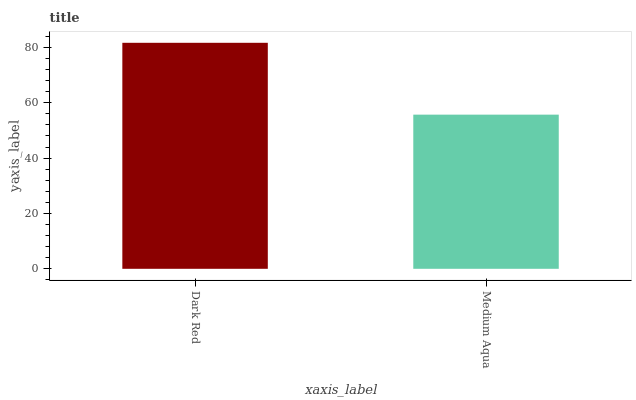Is Medium Aqua the maximum?
Answer yes or no. No. Is Dark Red greater than Medium Aqua?
Answer yes or no. Yes. Is Medium Aqua less than Dark Red?
Answer yes or no. Yes. Is Medium Aqua greater than Dark Red?
Answer yes or no. No. Is Dark Red less than Medium Aqua?
Answer yes or no. No. Is Dark Red the high median?
Answer yes or no. Yes. Is Medium Aqua the low median?
Answer yes or no. Yes. Is Medium Aqua the high median?
Answer yes or no. No. Is Dark Red the low median?
Answer yes or no. No. 